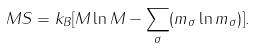Convert formula to latex. <formula><loc_0><loc_0><loc_500><loc_500>M S = k _ { B } [ M \ln M - \sum _ { \sigma } ( m _ { \sigma } \ln m _ { \sigma } ) ] .</formula> 